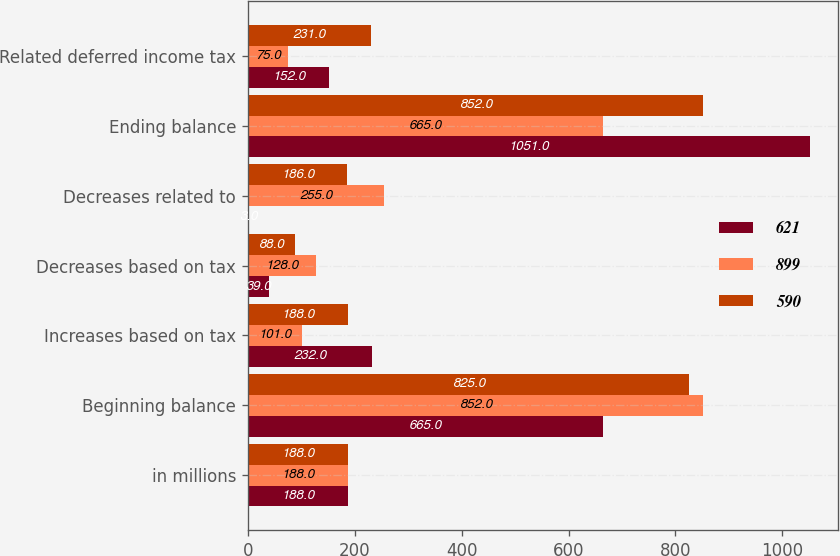Convert chart to OTSL. <chart><loc_0><loc_0><loc_500><loc_500><stacked_bar_chart><ecel><fcel>in millions<fcel>Beginning balance<fcel>Increases based on tax<fcel>Decreases based on tax<fcel>Decreases related to<fcel>Ending balance<fcel>Related deferred income tax<nl><fcel>621<fcel>188<fcel>665<fcel>232<fcel>39<fcel>3<fcel>1051<fcel>152<nl><fcel>899<fcel>188<fcel>852<fcel>101<fcel>128<fcel>255<fcel>665<fcel>75<nl><fcel>590<fcel>188<fcel>825<fcel>188<fcel>88<fcel>186<fcel>852<fcel>231<nl></chart> 